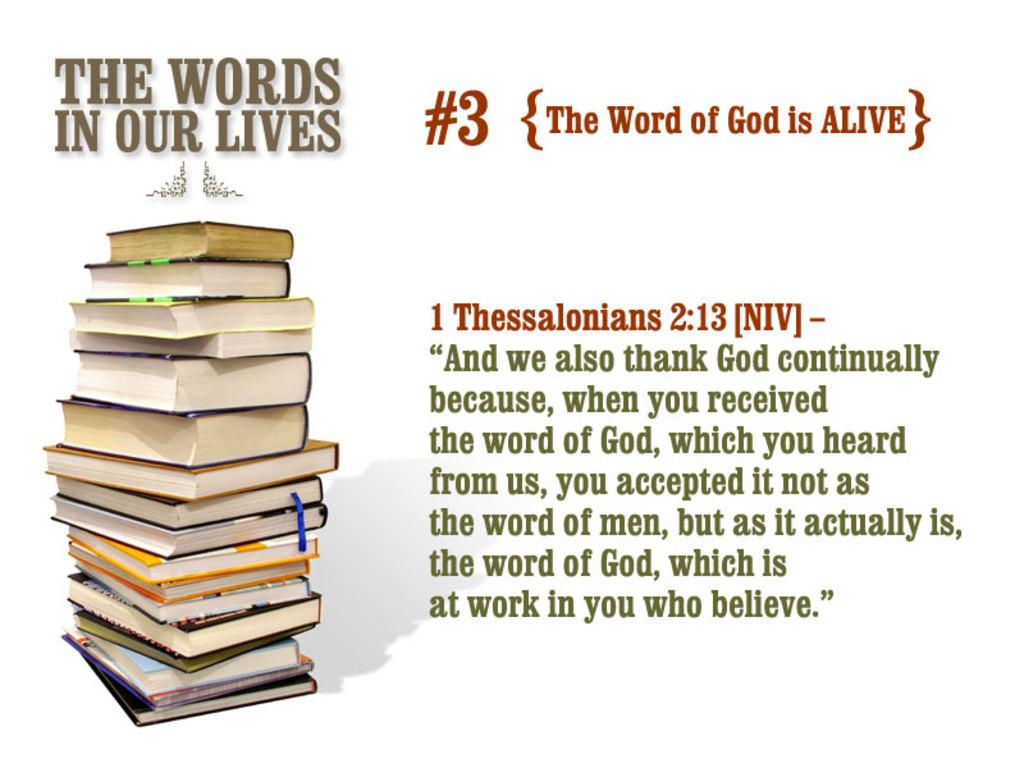<image>
Provide a brief description of the given image. Stack of books under some words that say "The Words In Our Lives". 